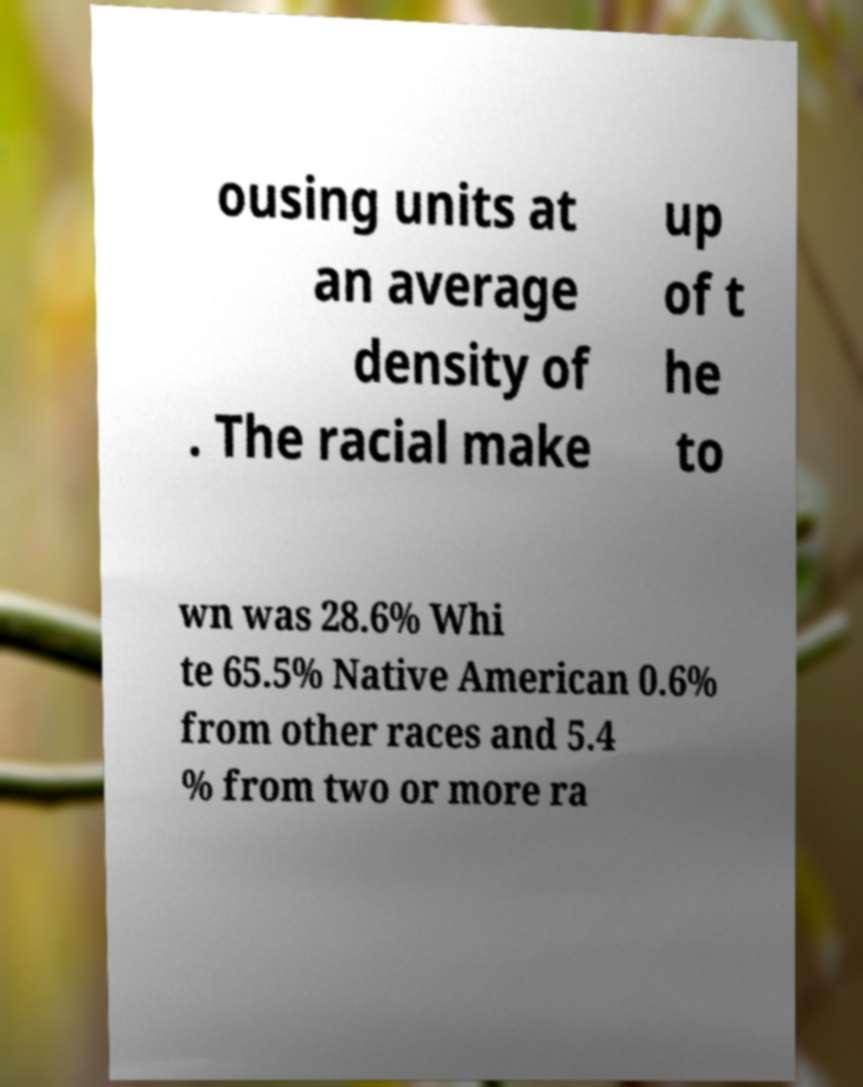I need the written content from this picture converted into text. Can you do that? ousing units at an average density of . The racial make up of t he to wn was 28.6% Whi te 65.5% Native American 0.6% from other races and 5.4 % from two or more ra 